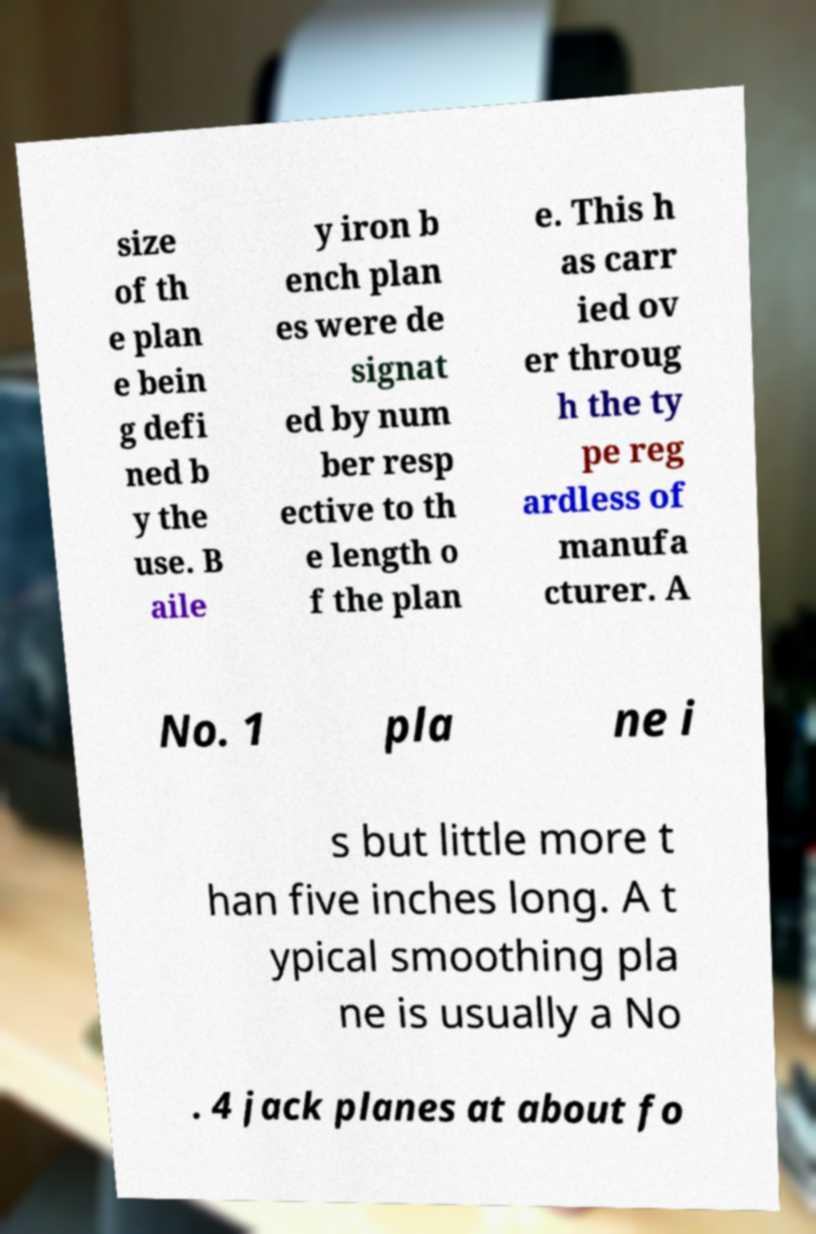There's text embedded in this image that I need extracted. Can you transcribe it verbatim? size of th e plan e bein g defi ned b y the use. B aile y iron b ench plan es were de signat ed by num ber resp ective to th e length o f the plan e. This h as carr ied ov er throug h the ty pe reg ardless of manufa cturer. A No. 1 pla ne i s but little more t han five inches long. A t ypical smoothing pla ne is usually a No . 4 jack planes at about fo 